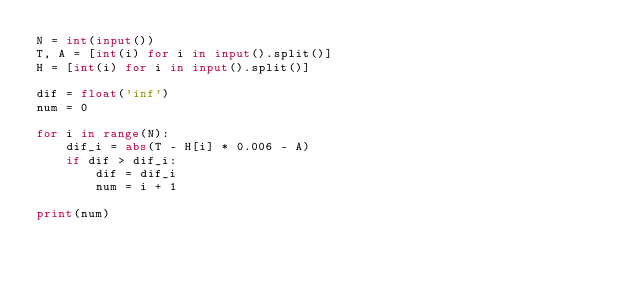<code> <loc_0><loc_0><loc_500><loc_500><_Python_>N = int(input())
T, A = [int(i) for i in input().split()]
H = [int(i) for i in input().split()]

dif = float('inf')
num = 0

for i in range(N):
    dif_i = abs(T - H[i] * 0.006 - A)
    if dif > dif_i:
        dif = dif_i
        num = i + 1

print(num)</code> 